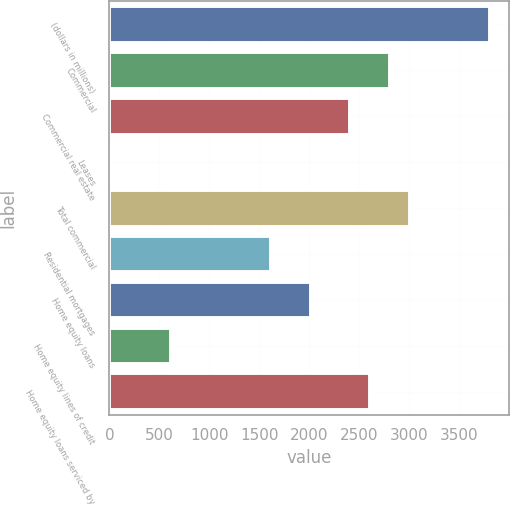Convert chart to OTSL. <chart><loc_0><loc_0><loc_500><loc_500><bar_chart><fcel>(dollars in millions)<fcel>Commercial<fcel>Commercial real estate<fcel>Leases<fcel>Total commercial<fcel>Residential mortgages<fcel>Home equity loans<fcel>Home equity lines of credit<fcel>Home equity loans serviced by<nl><fcel>3805.7<fcel>2809.2<fcel>2410.6<fcel>19<fcel>3008.5<fcel>1613.4<fcel>2012<fcel>616.9<fcel>2609.9<nl></chart> 